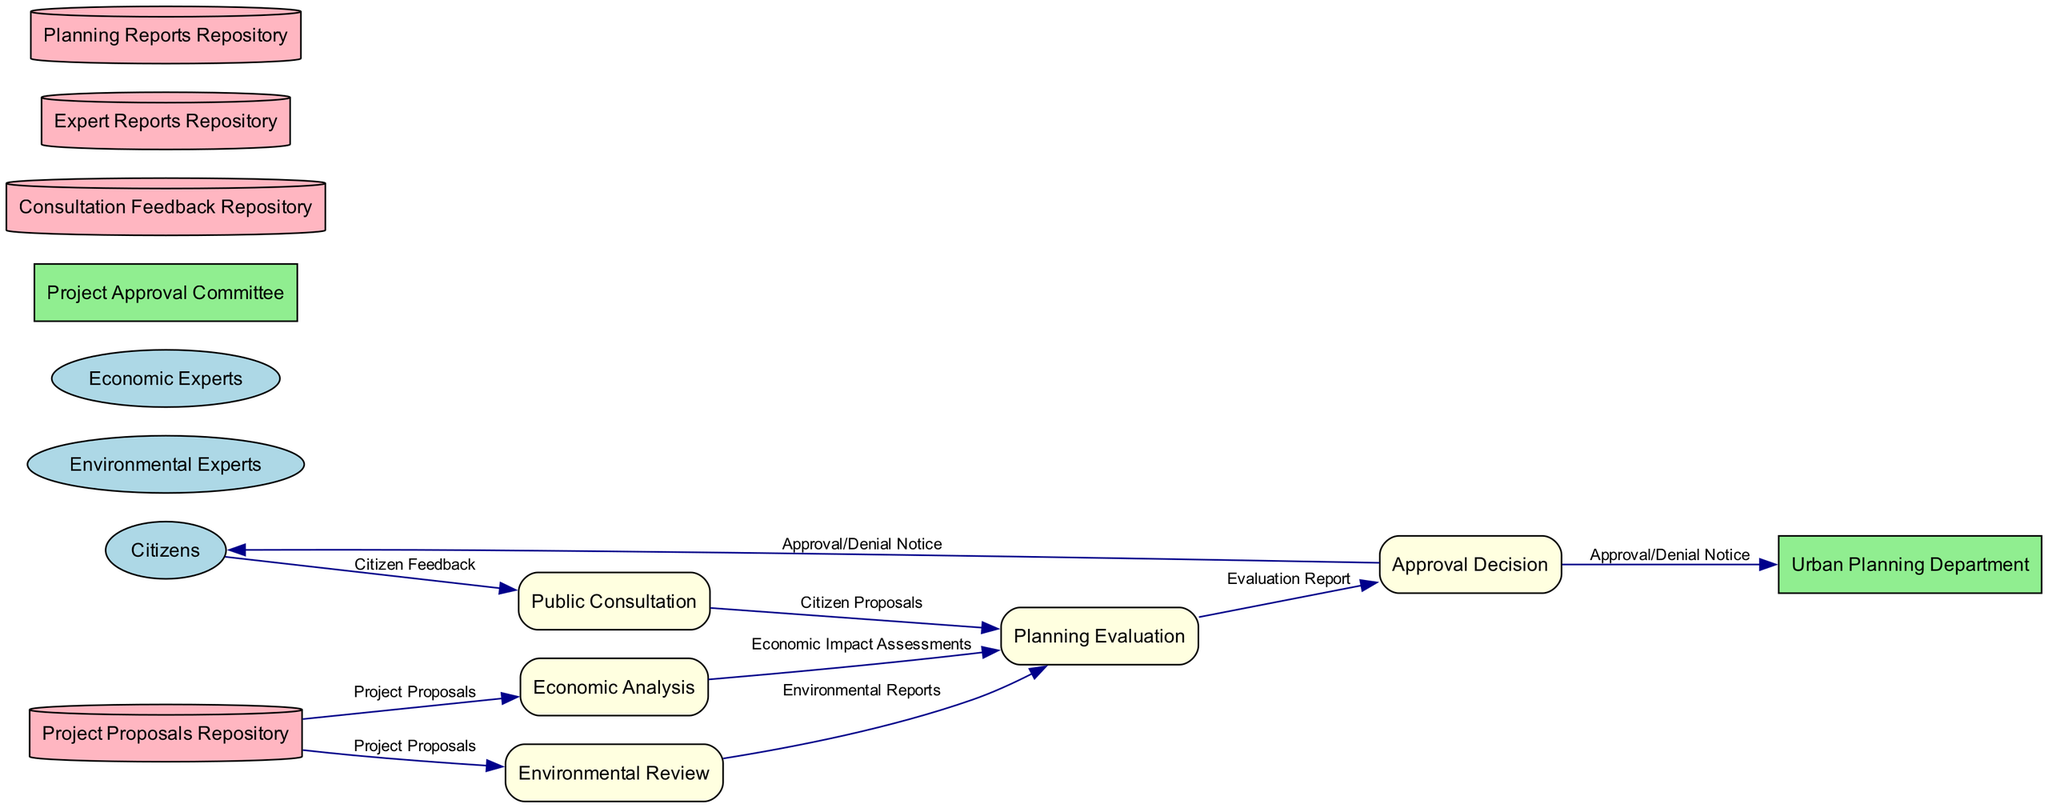What is the first entity in this diagram? The entities in the diagram are listed, and the first one is "Citizens."
Answer: Citizens How many internal entities are in the diagram? There are two internal entities: "Urban Planning Department" and "Project Approval Committee."
Answer: 2 What data do Environmental Experts provide to the Planning Evaluation? The Environmental Experts provide "Environmental Reports" after conducting the "Environmental Review" process.
Answer: Environmental Reports Which process converts citizen feedback into proposals? The "Public Consultation" process is where "Citizen Feedback" is transformed into "Citizen Proposals."
Answer: Public Consultation What are the inputs for the Planning Evaluation process? The inputs for the "Planning Evaluation" process are "Citizen Proposals," "Environmental Reports," and "Economic Impact Assessments."
Answer: Citizen Proposals, Environmental Reports, Economic Impact Assessments How many data flows originate from the Project Proposals Repository? There are two data flows that originate from the "Project Proposals Repository," one going to "Environmental Review" and one to "Economic Analysis."
Answer: 2 What is the final output of the Approval Decision process? The final output of the "Approval Decision" process is the "Approval/Denial Notice."
Answer: Approval/Denial Notice Who receives the output of the Approval Decision process? The output, which is the "Approval/Denial Notice," is sent to both "Citizens" and "Urban Planning Department."
Answer: Citizens, Urban Planning Department What type of diagram is this? This diagram is a Data Flow Diagram, as it illustrates the flow of data within the Urban Development Project Approval Process.
Answer: Data Flow Diagram 